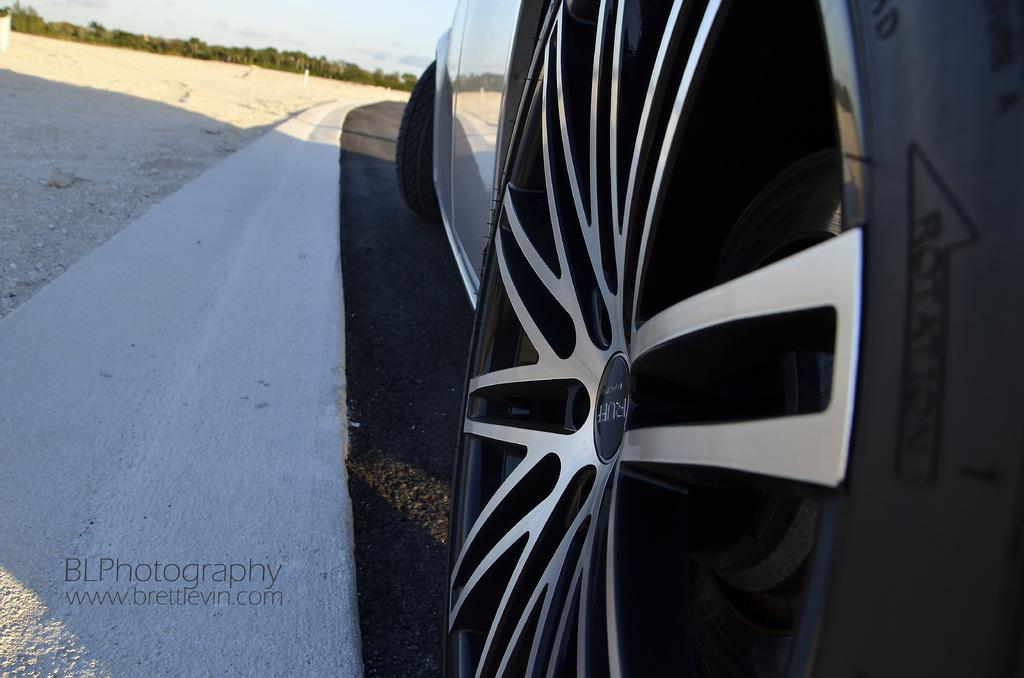What type of vehicle is in the image? The image contains a vehicle, but the specific type is not mentioned. Does the vehicle have any specific features? Yes, the vehicle has a tire. What is the setting of the image? The image features a road, sand, trees, and the sky. Can you describe the sky in the image? The sky is visible in the image. Is there any text or marking on the image? Yes, there is a watermark on the bottom left of the image. What type of protest is taking place in the image? There is no protest present in the image. What is the friction between the tire and the road in the image? The facts provided do not mention any details about the friction between the tire and the road. Who is the porter in the image? There is no porter present in the image. 